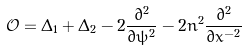<formula> <loc_0><loc_0><loc_500><loc_500>\mathcal { O } = \Delta _ { 1 } + \Delta _ { 2 } - 2 \frac { \partial ^ { 2 } } { \partial \psi ^ { 2 } } - 2 n ^ { 2 } \frac { \partial ^ { 2 } } { \partial x ^ { - 2 } }</formula> 